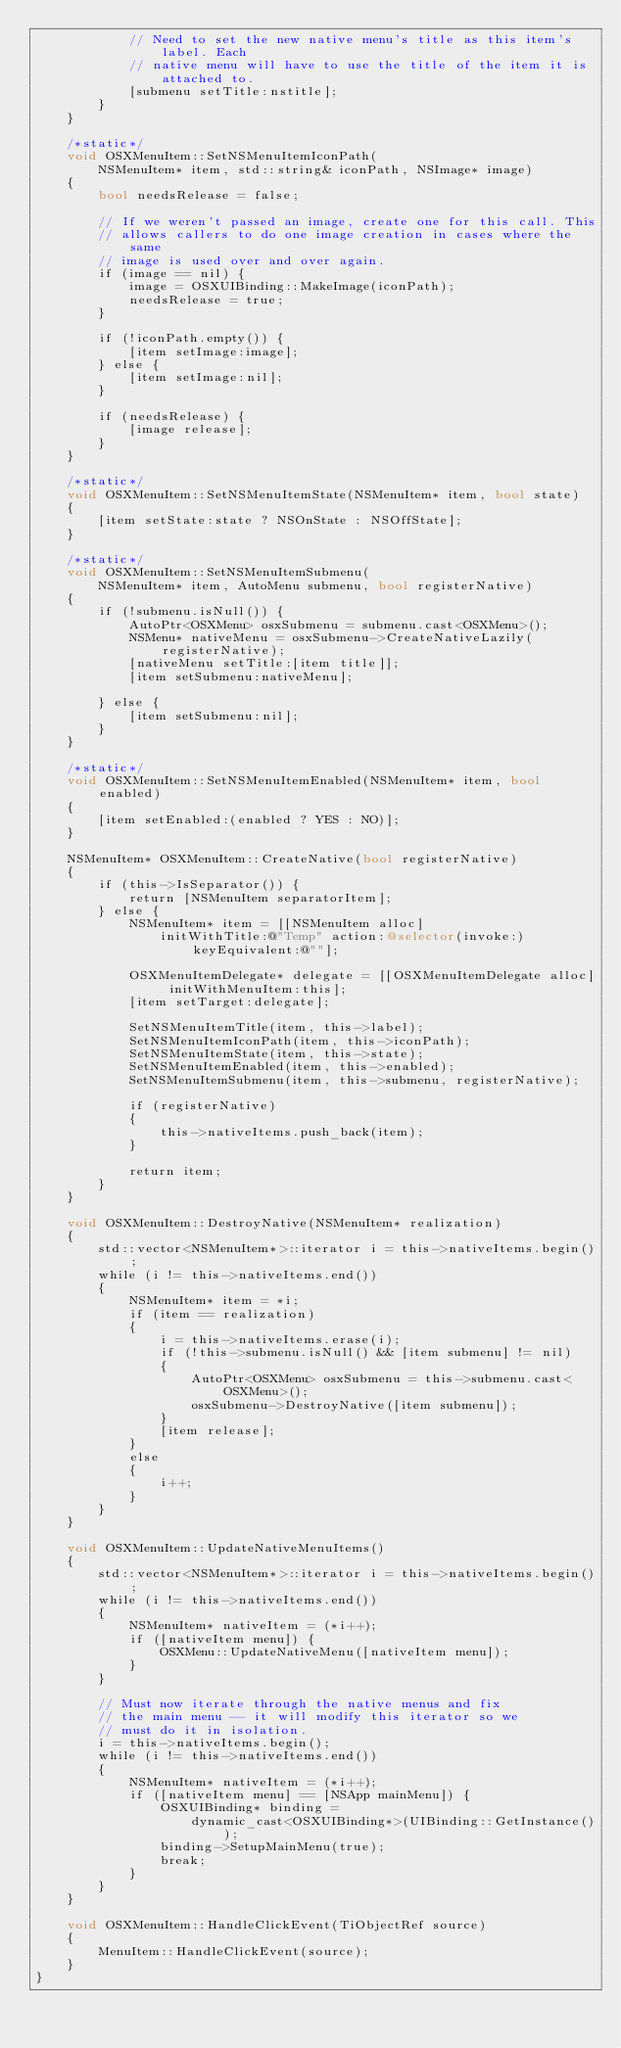Convert code to text. <code><loc_0><loc_0><loc_500><loc_500><_ObjectiveC_>            // Need to set the new native menu's title as this item's label. Each
            // native menu will have to use the title of the item it is attached to.
            [submenu setTitle:nstitle];
        }
    }

    /*static*/
    void OSXMenuItem::SetNSMenuItemIconPath(
        NSMenuItem* item, std::string& iconPath, NSImage* image)
    {
        bool needsRelease = false;

        // If we weren't passed an image, create one for this call. This
        // allows callers to do one image creation in cases where the same
        // image is used over and over again.
        if (image == nil) {
            image = OSXUIBinding::MakeImage(iconPath);
            needsRelease = true;
        }

        if (!iconPath.empty()) {
            [item setImage:image];
        } else {
            [item setImage:nil];
        }

        if (needsRelease) {
            [image release];
        }
    }

    /*static*/
    void OSXMenuItem::SetNSMenuItemState(NSMenuItem* item, bool state)
    {
        [item setState:state ? NSOnState : NSOffState];
    }

    /*static*/
    void OSXMenuItem::SetNSMenuItemSubmenu(
        NSMenuItem* item, AutoMenu submenu, bool registerNative)
    {
        if (!submenu.isNull()) {
            AutoPtr<OSXMenu> osxSubmenu = submenu.cast<OSXMenu>();
            NSMenu* nativeMenu = osxSubmenu->CreateNativeLazily(registerNative);
            [nativeMenu setTitle:[item title]];
            [item setSubmenu:nativeMenu];

        } else {
            [item setSubmenu:nil];
        }
    }

    /*static*/
    void OSXMenuItem::SetNSMenuItemEnabled(NSMenuItem* item, bool enabled)
    {
        [item setEnabled:(enabled ? YES : NO)];
    }

    NSMenuItem* OSXMenuItem::CreateNative(bool registerNative)
    {
        if (this->IsSeparator()) {
            return [NSMenuItem separatorItem];
        } else {
            NSMenuItem* item = [[NSMenuItem alloc] 
                initWithTitle:@"Temp" action:@selector(invoke:) keyEquivalent:@""];

            OSXMenuItemDelegate* delegate = [[OSXMenuItemDelegate alloc] initWithMenuItem:this];
            [item setTarget:delegate];

            SetNSMenuItemTitle(item, this->label);
            SetNSMenuItemIconPath(item, this->iconPath);
            SetNSMenuItemState(item, this->state);
            SetNSMenuItemEnabled(item, this->enabled);
            SetNSMenuItemSubmenu(item, this->submenu, registerNative);

            if (registerNative)
            {
                this->nativeItems.push_back(item);
            }

            return item;
        }
    }

    void OSXMenuItem::DestroyNative(NSMenuItem* realization)
    {
        std::vector<NSMenuItem*>::iterator i = this->nativeItems.begin();
        while (i != this->nativeItems.end())
        {
            NSMenuItem* item = *i;
            if (item == realization)
            {
                i = this->nativeItems.erase(i);
                if (!this->submenu.isNull() && [item submenu] != nil)
                {
                    AutoPtr<OSXMenu> osxSubmenu = this->submenu.cast<OSXMenu>();
                    osxSubmenu->DestroyNative([item submenu]);
                }
                [item release];
            }
            else
            {
                i++;
            }
        }
    }

    void OSXMenuItem::UpdateNativeMenuItems()
    {
        std::vector<NSMenuItem*>::iterator i = this->nativeItems.begin();
        while (i != this->nativeItems.end())
        {
            NSMenuItem* nativeItem = (*i++);
            if ([nativeItem menu]) {
                OSXMenu::UpdateNativeMenu([nativeItem menu]);
            }
        }

        // Must now iterate through the native menus and fix
        // the main menu -- it will modify this iterator so we
        // must do it in isolation.
        i = this->nativeItems.begin();
        while (i != this->nativeItems.end())
        {
            NSMenuItem* nativeItem = (*i++);
            if ([nativeItem menu] == [NSApp mainMenu]) {
                OSXUIBinding* binding =
                    dynamic_cast<OSXUIBinding*>(UIBinding::GetInstance());
                binding->SetupMainMenu(true);
                break;
            }
        }
    }

    void OSXMenuItem::HandleClickEvent(TiObjectRef source)
    {
        MenuItem::HandleClickEvent(source);
    }
}


</code> 